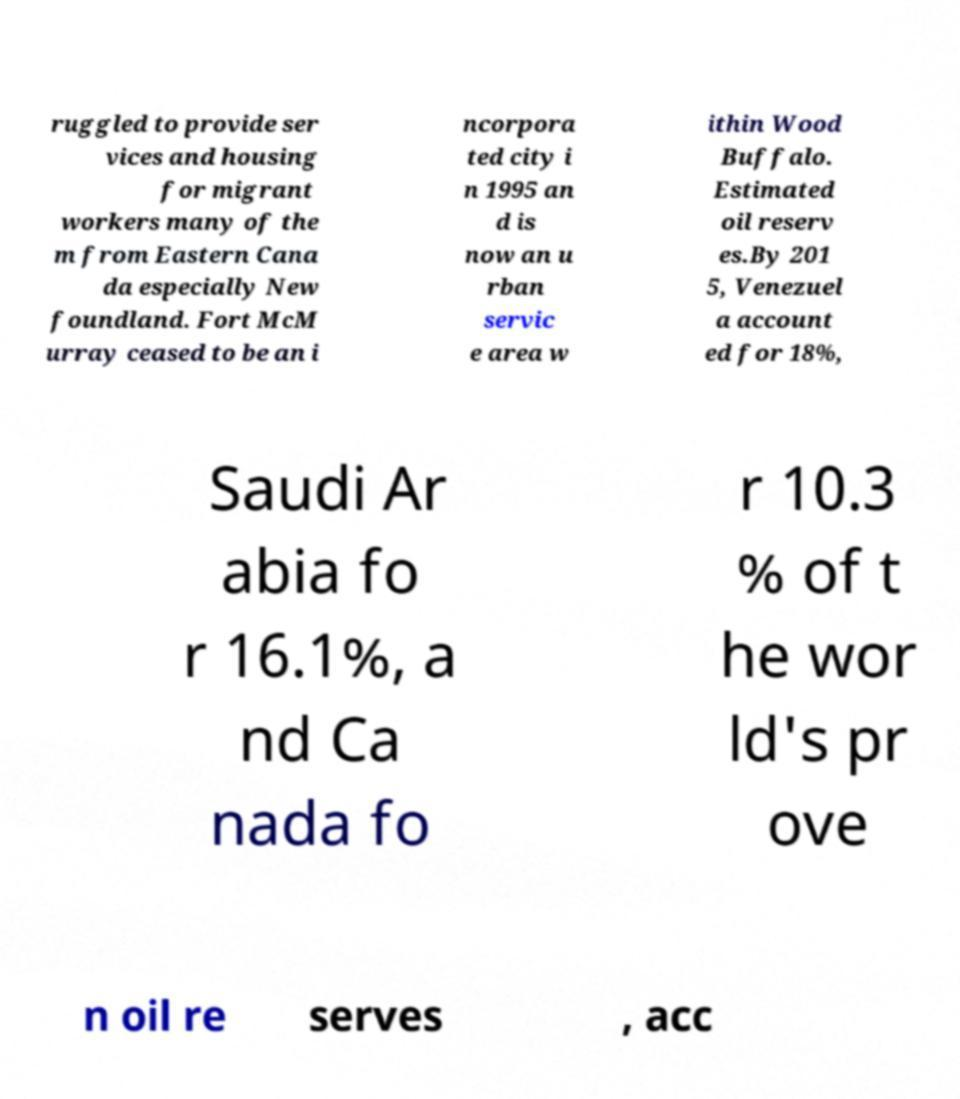Please identify and transcribe the text found in this image. ruggled to provide ser vices and housing for migrant workers many of the m from Eastern Cana da especially New foundland. Fort McM urray ceased to be an i ncorpora ted city i n 1995 an d is now an u rban servic e area w ithin Wood Buffalo. Estimated oil reserv es.By 201 5, Venezuel a account ed for 18%, Saudi Ar abia fo r 16.1%, a nd Ca nada fo r 10.3 % of t he wor ld's pr ove n oil re serves , acc 